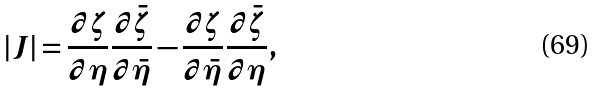Convert formula to latex. <formula><loc_0><loc_0><loc_500><loc_500>| J | = \frac { \partial \zeta } { \partial \eta } \frac { \partial \bar { \zeta } } { \partial \bar { \eta } } - \frac { \partial \zeta } { \partial \bar { \eta } } \frac { \partial \bar { \zeta } } { \partial \eta } ,</formula> 